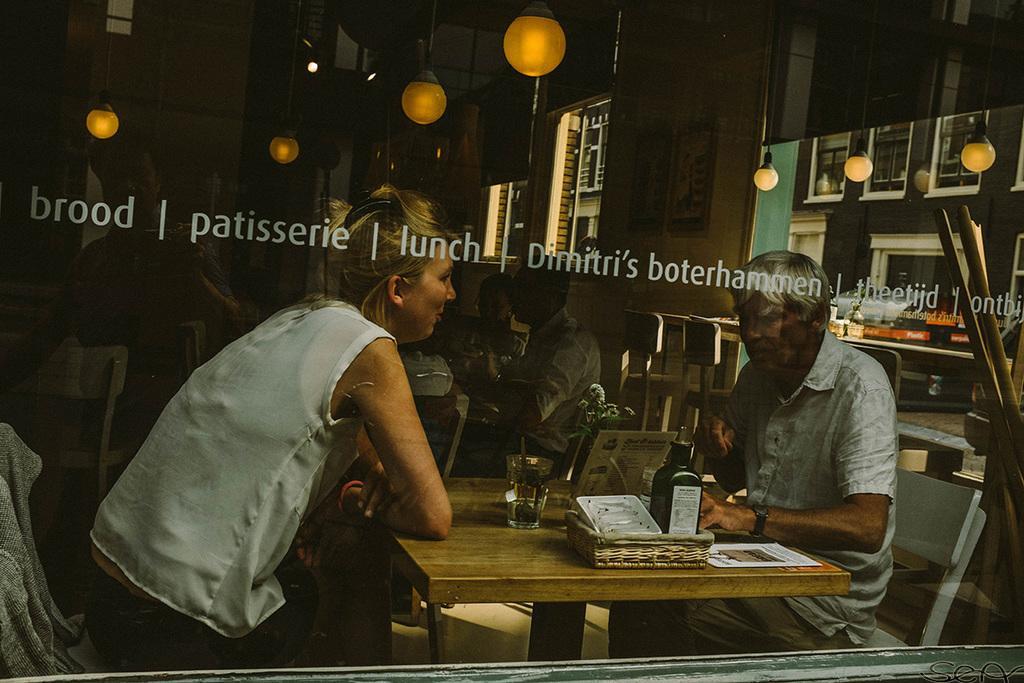Could you give a brief overview of what you see in this image? In the image there is a woman and old man sat on chair in front of table,there is a glass and bottle on the table. in the ceiling there are hanging lights, it seems to be of hotel and the background it seems to be of kitchen. 